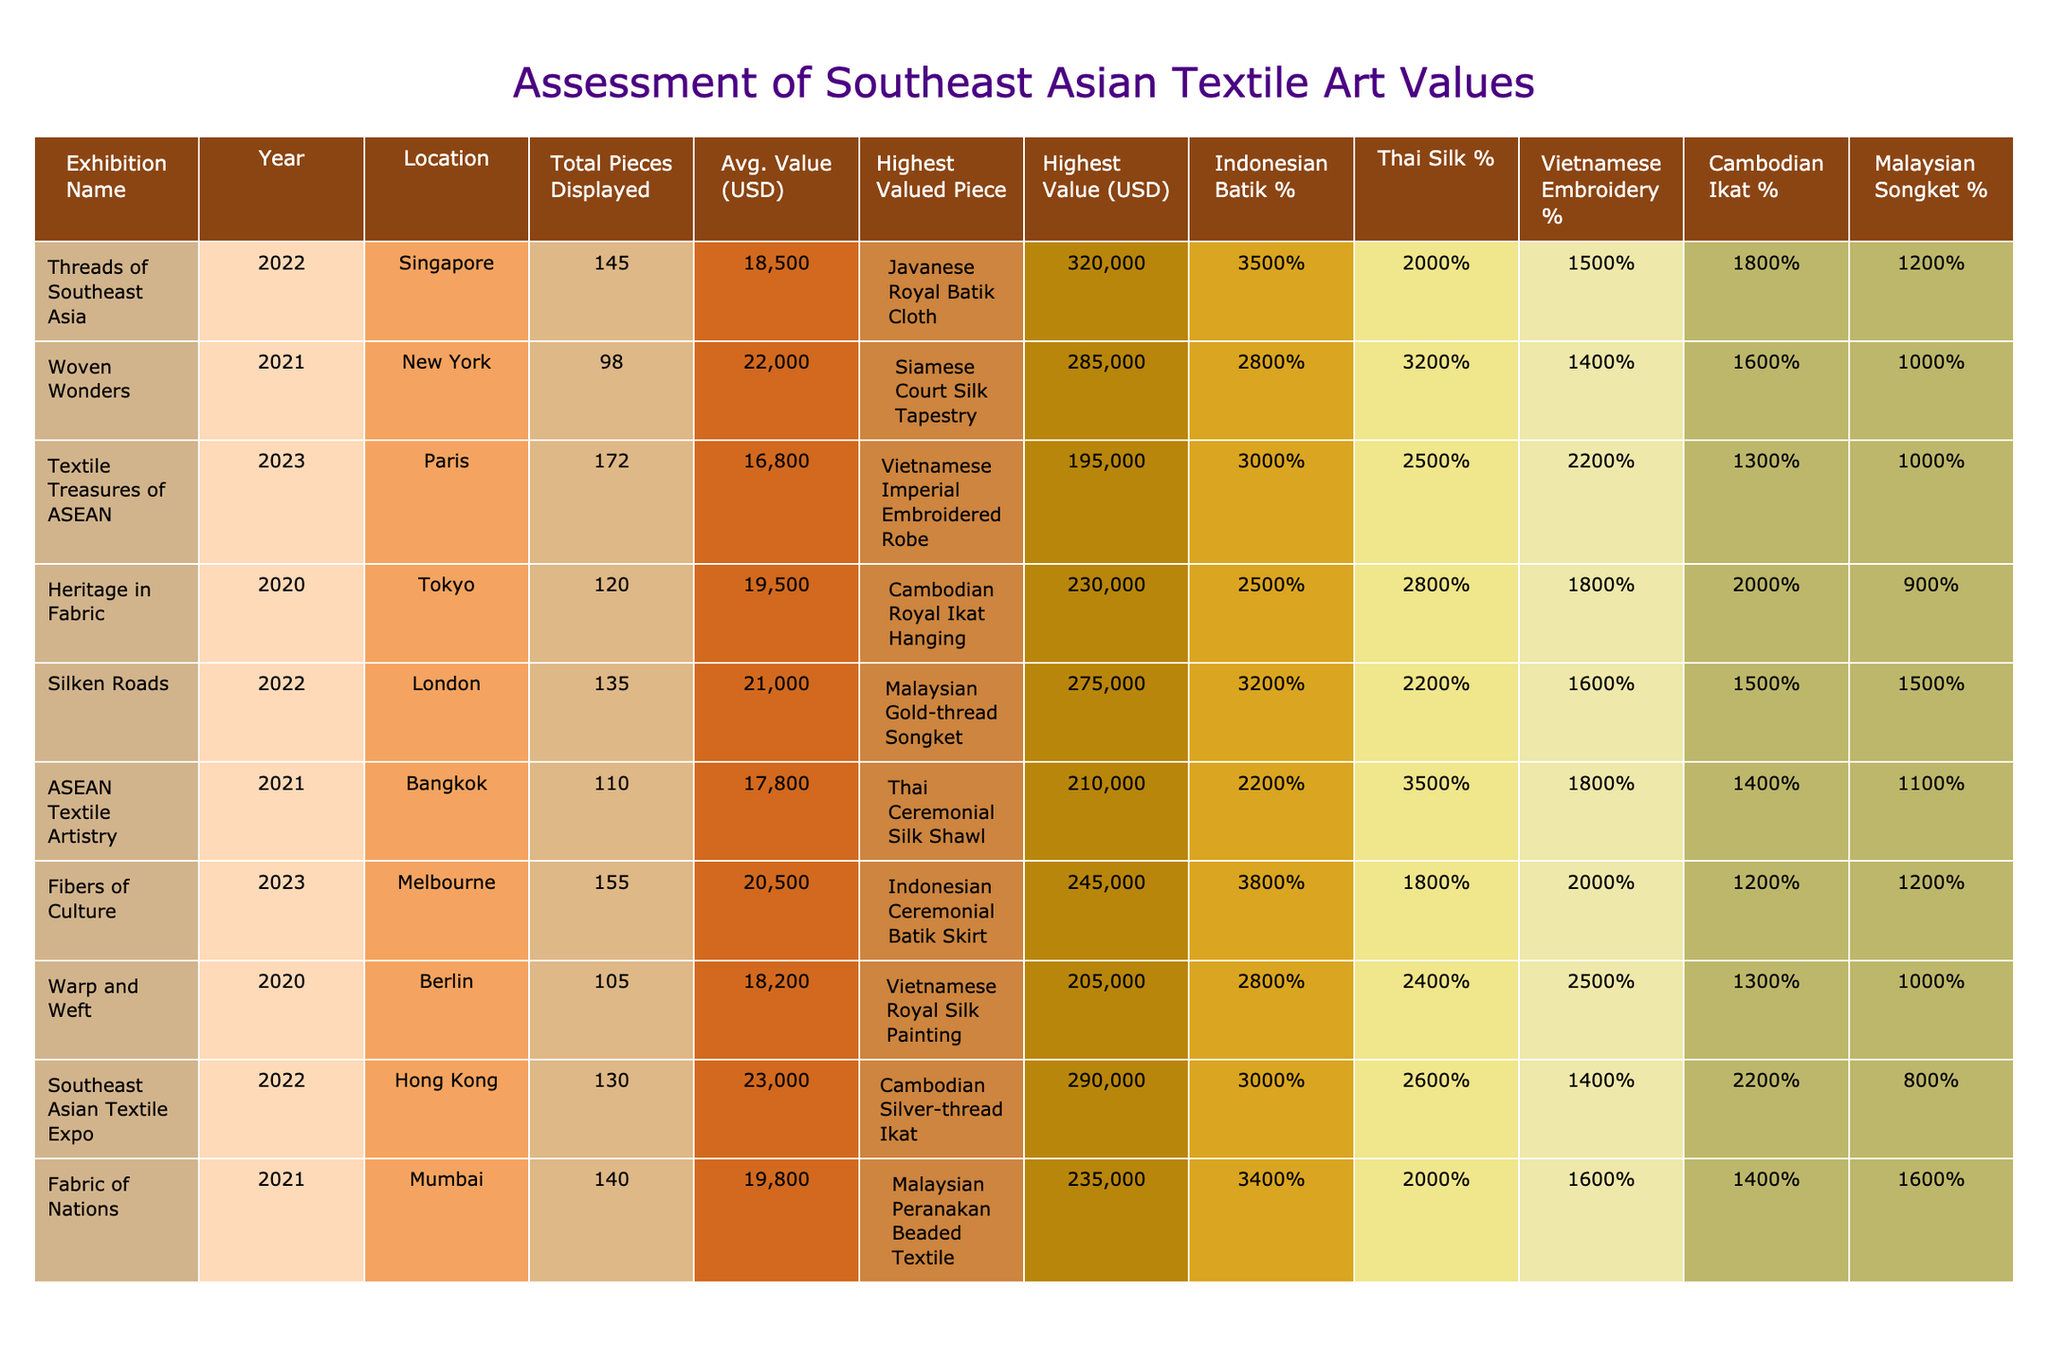What is the highest valued piece displayed in the exhibition "Woven Wonders"? According to the table, the highest valued piece in "Woven Wonders" is the "Siamese Court Silk Tapestry", which has a value of 285,000 USD.
Answer: Siamese Court Silk Tapestry In which year was the exhibition "Textile Treasures of ASEAN" held? The table indicates that "Textile Treasures of ASEAN" was held in the year 2023.
Answer: 2023 What percentage of pieces displayed in the "Silken Roads" exhibition were Malaysian Songket? The table shows that 15% of the pieces displayed in the "Silken Roads" exhibition were Malaysian Songket.
Answer: 15% Which exhibition had the smallest average value of displayed pieces? By comparing the average values in the table, "Textile Treasures of ASEAN" has the smallest average value at 16,800 USD.
Answer: Textile Treasures of ASEAN What is the difference in average value between "Threads of Southeast Asia" and "Heritage in Fabric"? The average value for "Threads of Southeast Asia" is 18,500 USD and for "Heritage in Fabric" it's 19,500 USD. The difference is 19,500 - 18,500 = 1,000 USD.
Answer: 1,000 USD Which exhibition had the highest percentage of Indonesian Batik displayed, and what was that percentage? "Fibers of Culture" displayed the highest percentage of Indonesian Batik at 38%, as stated in the table.
Answer: 38% What is the total number of pieces displayed across all exhibitions? Summing the "Total Pieces Displayed" from all exhibitions (145 + 98 + 172 + 120 + 135 + 110 + 155 + 105 + 130 + 140) gives a total of 1,410 pieces.
Answer: 1,410 pieces Is the highest value piece in the "Southeast Asian Textile Expo" a Cambodian piece? The highest value piece in the "Southeast Asian Textile Expo" is "Cambodian Silver-thread Ikat", indicating that it is indeed a Cambodian piece. Thus, the answer is yes.
Answer: Yes Which location featured the exhibition with the average value closest to 20,000 USD? The average values for exhibitions are compared and "Heritage in Fabric" in Tokyo has an average value of 19,500 USD, which is closest to 20,000 USD.
Answer: Tokyo What is the average value of the exhibitions held in 2021? The average values for the exhibitions held in 2021 are "Woven Wonders" (22,000 USD), "ASEAN Textile Artistry" (17,800 USD), and "Fabric of Nations" (19,800 USD). The average is calculated as (22,000 + 17,800 + 19,800) / 3 = 19,533.33 USD.
Answer: 19,533.33 USD 